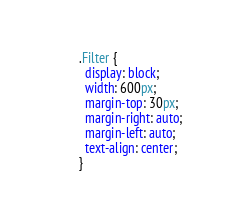Convert code to text. <code><loc_0><loc_0><loc_500><loc_500><_CSS_>.Filter {
  display: block;
  width: 600px;
  margin-top: 30px;
  margin-right: auto;
  margin-left: auto;
  text-align: center;
}
</code> 